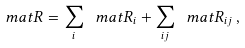<formula> <loc_0><loc_0><loc_500><loc_500>\ m a t R = \sum _ { i } \ m a t R _ { i } + \sum _ { i j } \ m a t R _ { i j } \, ,</formula> 